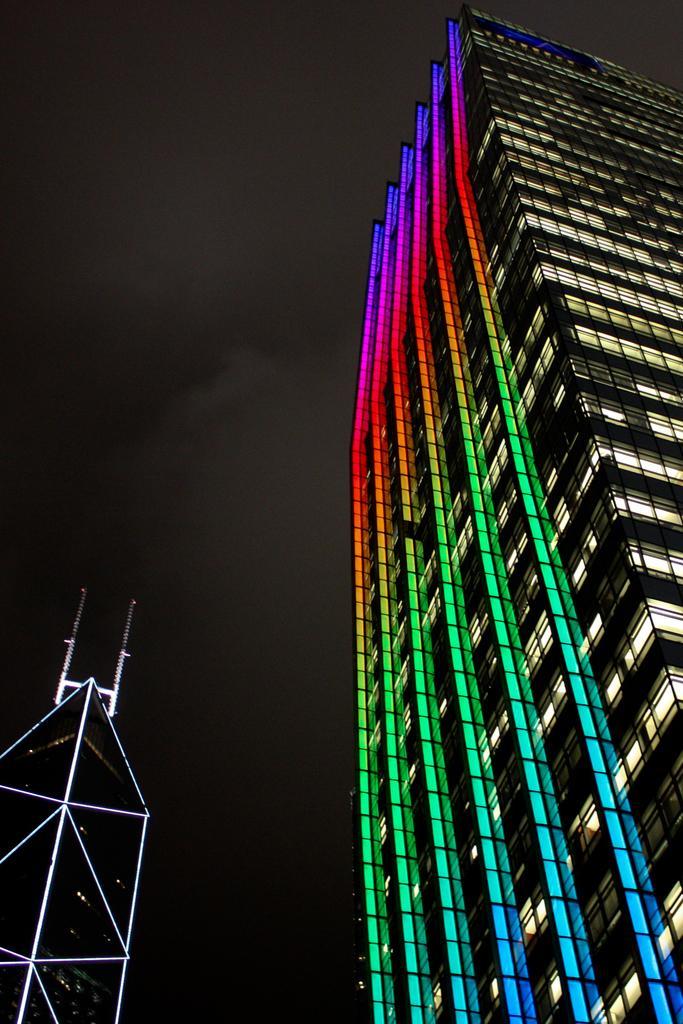Could you give a brief overview of what you see in this image? In this image I can see a building on the right side. On this building I can see colourful lights. 